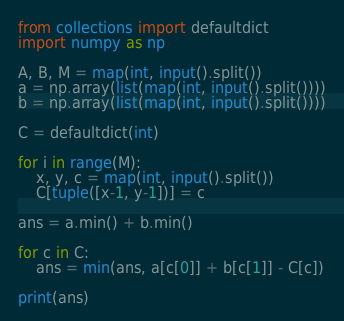Convert code to text. <code><loc_0><loc_0><loc_500><loc_500><_Python_>from collections import defaultdict
import numpy as np

A, B, M = map(int, input().split())
a = np.array(list(map(int, input().split())))
b = np.array(list(map(int, input().split())))

C = defaultdict(int)

for i in range(M):
    x, y, c = map(int, input().split())
    C[tuple([x-1, y-1])] = c

ans = a.min() + b.min()

for c in C:
    ans = min(ans, a[c[0]] + b[c[1]] - C[c])
    
print(ans)</code> 